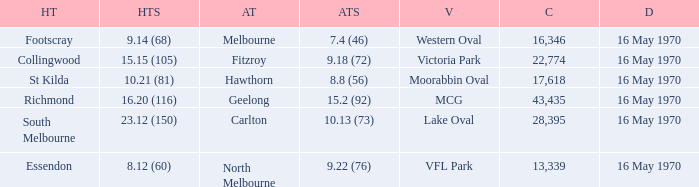What's the venue for the home team that scored 9.14 (68)? Western Oval. 